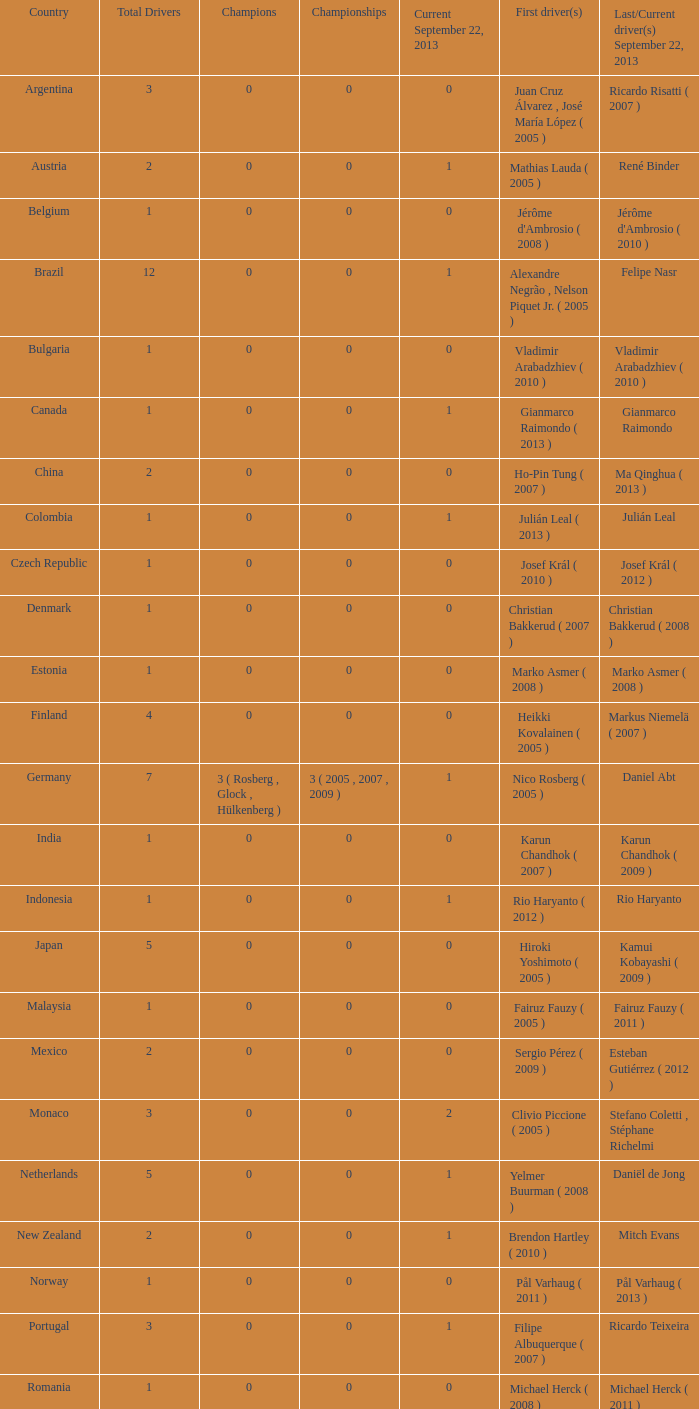How many drivers are listed in total when the concluding driver for september 22, 2013 was gianmarco raimondo? 1.0. 